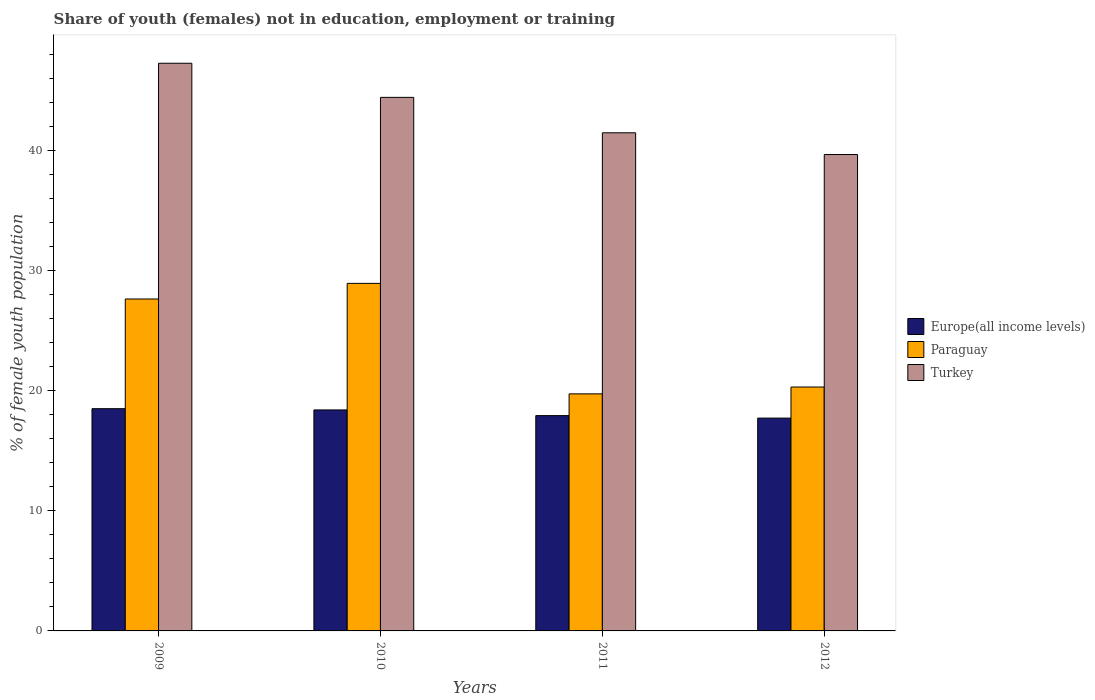How many different coloured bars are there?
Offer a terse response. 3. Are the number of bars per tick equal to the number of legend labels?
Ensure brevity in your answer.  Yes. What is the percentage of unemployed female population in in Europe(all income levels) in 2010?
Make the answer very short. 18.4. Across all years, what is the maximum percentage of unemployed female population in in Europe(all income levels)?
Your response must be concise. 18.51. Across all years, what is the minimum percentage of unemployed female population in in Turkey?
Your answer should be compact. 39.67. What is the total percentage of unemployed female population in in Turkey in the graph?
Your response must be concise. 172.85. What is the difference between the percentage of unemployed female population in in Turkey in 2009 and that in 2010?
Your response must be concise. 2.84. What is the difference between the percentage of unemployed female population in in Paraguay in 2011 and the percentage of unemployed female population in in Turkey in 2009?
Your response must be concise. -27.53. What is the average percentage of unemployed female population in in Turkey per year?
Give a very brief answer. 43.21. In the year 2011, what is the difference between the percentage of unemployed female population in in Europe(all income levels) and percentage of unemployed female population in in Paraguay?
Your response must be concise. -1.81. What is the ratio of the percentage of unemployed female population in in Europe(all income levels) in 2010 to that in 2012?
Your answer should be very brief. 1.04. Is the percentage of unemployed female population in in Paraguay in 2009 less than that in 2011?
Offer a terse response. No. Is the difference between the percentage of unemployed female population in in Europe(all income levels) in 2009 and 2012 greater than the difference between the percentage of unemployed female population in in Paraguay in 2009 and 2012?
Offer a very short reply. No. What is the difference between the highest and the second highest percentage of unemployed female population in in Turkey?
Make the answer very short. 2.84. What is the difference between the highest and the lowest percentage of unemployed female population in in Turkey?
Your response must be concise. 7.6. In how many years, is the percentage of unemployed female population in in Europe(all income levels) greater than the average percentage of unemployed female population in in Europe(all income levels) taken over all years?
Provide a succinct answer. 2. Is the sum of the percentage of unemployed female population in in Paraguay in 2009 and 2011 greater than the maximum percentage of unemployed female population in in Europe(all income levels) across all years?
Give a very brief answer. Yes. What does the 1st bar from the left in 2012 represents?
Offer a terse response. Europe(all income levels). What does the 3rd bar from the right in 2010 represents?
Your answer should be very brief. Europe(all income levels). Are all the bars in the graph horizontal?
Provide a succinct answer. No. How many years are there in the graph?
Offer a terse response. 4. What is the difference between two consecutive major ticks on the Y-axis?
Provide a succinct answer. 10. Where does the legend appear in the graph?
Provide a short and direct response. Center right. How many legend labels are there?
Ensure brevity in your answer.  3. What is the title of the graph?
Give a very brief answer. Share of youth (females) not in education, employment or training. What is the label or title of the X-axis?
Offer a terse response. Years. What is the label or title of the Y-axis?
Keep it short and to the point. % of female youth population. What is the % of female youth population in Europe(all income levels) in 2009?
Your answer should be very brief. 18.51. What is the % of female youth population in Paraguay in 2009?
Give a very brief answer. 27.64. What is the % of female youth population of Turkey in 2009?
Offer a terse response. 47.27. What is the % of female youth population in Europe(all income levels) in 2010?
Your answer should be very brief. 18.4. What is the % of female youth population in Paraguay in 2010?
Provide a succinct answer. 28.94. What is the % of female youth population of Turkey in 2010?
Provide a short and direct response. 44.43. What is the % of female youth population in Europe(all income levels) in 2011?
Your answer should be compact. 17.93. What is the % of female youth population in Paraguay in 2011?
Give a very brief answer. 19.74. What is the % of female youth population of Turkey in 2011?
Offer a very short reply. 41.48. What is the % of female youth population in Europe(all income levels) in 2012?
Your answer should be very brief. 17.72. What is the % of female youth population of Paraguay in 2012?
Your answer should be compact. 20.31. What is the % of female youth population in Turkey in 2012?
Offer a terse response. 39.67. Across all years, what is the maximum % of female youth population of Europe(all income levels)?
Your answer should be very brief. 18.51. Across all years, what is the maximum % of female youth population in Paraguay?
Offer a terse response. 28.94. Across all years, what is the maximum % of female youth population in Turkey?
Your response must be concise. 47.27. Across all years, what is the minimum % of female youth population of Europe(all income levels)?
Keep it short and to the point. 17.72. Across all years, what is the minimum % of female youth population in Paraguay?
Offer a terse response. 19.74. Across all years, what is the minimum % of female youth population of Turkey?
Offer a very short reply. 39.67. What is the total % of female youth population in Europe(all income levels) in the graph?
Give a very brief answer. 72.56. What is the total % of female youth population in Paraguay in the graph?
Give a very brief answer. 96.63. What is the total % of female youth population of Turkey in the graph?
Keep it short and to the point. 172.85. What is the difference between the % of female youth population in Europe(all income levels) in 2009 and that in 2010?
Provide a succinct answer. 0.1. What is the difference between the % of female youth population in Paraguay in 2009 and that in 2010?
Make the answer very short. -1.3. What is the difference between the % of female youth population of Turkey in 2009 and that in 2010?
Make the answer very short. 2.84. What is the difference between the % of female youth population in Europe(all income levels) in 2009 and that in 2011?
Make the answer very short. 0.58. What is the difference between the % of female youth population of Turkey in 2009 and that in 2011?
Provide a short and direct response. 5.79. What is the difference between the % of female youth population in Europe(all income levels) in 2009 and that in 2012?
Keep it short and to the point. 0.79. What is the difference between the % of female youth population of Paraguay in 2009 and that in 2012?
Keep it short and to the point. 7.33. What is the difference between the % of female youth population of Europe(all income levels) in 2010 and that in 2011?
Ensure brevity in your answer.  0.47. What is the difference between the % of female youth population in Paraguay in 2010 and that in 2011?
Ensure brevity in your answer.  9.2. What is the difference between the % of female youth population in Turkey in 2010 and that in 2011?
Give a very brief answer. 2.95. What is the difference between the % of female youth population in Europe(all income levels) in 2010 and that in 2012?
Provide a succinct answer. 0.68. What is the difference between the % of female youth population in Paraguay in 2010 and that in 2012?
Your answer should be compact. 8.63. What is the difference between the % of female youth population of Turkey in 2010 and that in 2012?
Your answer should be compact. 4.76. What is the difference between the % of female youth population of Europe(all income levels) in 2011 and that in 2012?
Give a very brief answer. 0.21. What is the difference between the % of female youth population of Paraguay in 2011 and that in 2012?
Provide a succinct answer. -0.57. What is the difference between the % of female youth population of Turkey in 2011 and that in 2012?
Your answer should be very brief. 1.81. What is the difference between the % of female youth population in Europe(all income levels) in 2009 and the % of female youth population in Paraguay in 2010?
Provide a succinct answer. -10.43. What is the difference between the % of female youth population in Europe(all income levels) in 2009 and the % of female youth population in Turkey in 2010?
Offer a very short reply. -25.92. What is the difference between the % of female youth population in Paraguay in 2009 and the % of female youth population in Turkey in 2010?
Your answer should be compact. -16.79. What is the difference between the % of female youth population of Europe(all income levels) in 2009 and the % of female youth population of Paraguay in 2011?
Provide a succinct answer. -1.23. What is the difference between the % of female youth population of Europe(all income levels) in 2009 and the % of female youth population of Turkey in 2011?
Make the answer very short. -22.97. What is the difference between the % of female youth population in Paraguay in 2009 and the % of female youth population in Turkey in 2011?
Your answer should be compact. -13.84. What is the difference between the % of female youth population in Europe(all income levels) in 2009 and the % of female youth population in Paraguay in 2012?
Make the answer very short. -1.8. What is the difference between the % of female youth population of Europe(all income levels) in 2009 and the % of female youth population of Turkey in 2012?
Provide a short and direct response. -21.16. What is the difference between the % of female youth population in Paraguay in 2009 and the % of female youth population in Turkey in 2012?
Your response must be concise. -12.03. What is the difference between the % of female youth population of Europe(all income levels) in 2010 and the % of female youth population of Paraguay in 2011?
Give a very brief answer. -1.34. What is the difference between the % of female youth population of Europe(all income levels) in 2010 and the % of female youth population of Turkey in 2011?
Offer a very short reply. -23.08. What is the difference between the % of female youth population of Paraguay in 2010 and the % of female youth population of Turkey in 2011?
Offer a very short reply. -12.54. What is the difference between the % of female youth population in Europe(all income levels) in 2010 and the % of female youth population in Paraguay in 2012?
Keep it short and to the point. -1.91. What is the difference between the % of female youth population in Europe(all income levels) in 2010 and the % of female youth population in Turkey in 2012?
Your answer should be very brief. -21.27. What is the difference between the % of female youth population of Paraguay in 2010 and the % of female youth population of Turkey in 2012?
Offer a very short reply. -10.73. What is the difference between the % of female youth population in Europe(all income levels) in 2011 and the % of female youth population in Paraguay in 2012?
Your response must be concise. -2.38. What is the difference between the % of female youth population of Europe(all income levels) in 2011 and the % of female youth population of Turkey in 2012?
Offer a very short reply. -21.74. What is the difference between the % of female youth population of Paraguay in 2011 and the % of female youth population of Turkey in 2012?
Offer a very short reply. -19.93. What is the average % of female youth population of Europe(all income levels) per year?
Offer a terse response. 18.14. What is the average % of female youth population in Paraguay per year?
Offer a terse response. 24.16. What is the average % of female youth population of Turkey per year?
Provide a short and direct response. 43.21. In the year 2009, what is the difference between the % of female youth population in Europe(all income levels) and % of female youth population in Paraguay?
Make the answer very short. -9.13. In the year 2009, what is the difference between the % of female youth population in Europe(all income levels) and % of female youth population in Turkey?
Ensure brevity in your answer.  -28.76. In the year 2009, what is the difference between the % of female youth population in Paraguay and % of female youth population in Turkey?
Provide a short and direct response. -19.63. In the year 2010, what is the difference between the % of female youth population of Europe(all income levels) and % of female youth population of Paraguay?
Give a very brief answer. -10.54. In the year 2010, what is the difference between the % of female youth population of Europe(all income levels) and % of female youth population of Turkey?
Make the answer very short. -26.03. In the year 2010, what is the difference between the % of female youth population in Paraguay and % of female youth population in Turkey?
Your response must be concise. -15.49. In the year 2011, what is the difference between the % of female youth population of Europe(all income levels) and % of female youth population of Paraguay?
Keep it short and to the point. -1.81. In the year 2011, what is the difference between the % of female youth population in Europe(all income levels) and % of female youth population in Turkey?
Provide a short and direct response. -23.55. In the year 2011, what is the difference between the % of female youth population in Paraguay and % of female youth population in Turkey?
Offer a very short reply. -21.74. In the year 2012, what is the difference between the % of female youth population of Europe(all income levels) and % of female youth population of Paraguay?
Provide a succinct answer. -2.59. In the year 2012, what is the difference between the % of female youth population of Europe(all income levels) and % of female youth population of Turkey?
Your response must be concise. -21.95. In the year 2012, what is the difference between the % of female youth population of Paraguay and % of female youth population of Turkey?
Provide a short and direct response. -19.36. What is the ratio of the % of female youth population of Paraguay in 2009 to that in 2010?
Your response must be concise. 0.96. What is the ratio of the % of female youth population of Turkey in 2009 to that in 2010?
Keep it short and to the point. 1.06. What is the ratio of the % of female youth population in Europe(all income levels) in 2009 to that in 2011?
Provide a succinct answer. 1.03. What is the ratio of the % of female youth population of Paraguay in 2009 to that in 2011?
Your response must be concise. 1.4. What is the ratio of the % of female youth population of Turkey in 2009 to that in 2011?
Make the answer very short. 1.14. What is the ratio of the % of female youth population in Europe(all income levels) in 2009 to that in 2012?
Keep it short and to the point. 1.04. What is the ratio of the % of female youth population of Paraguay in 2009 to that in 2012?
Keep it short and to the point. 1.36. What is the ratio of the % of female youth population of Turkey in 2009 to that in 2012?
Your answer should be very brief. 1.19. What is the ratio of the % of female youth population in Europe(all income levels) in 2010 to that in 2011?
Provide a succinct answer. 1.03. What is the ratio of the % of female youth population of Paraguay in 2010 to that in 2011?
Your answer should be compact. 1.47. What is the ratio of the % of female youth population in Turkey in 2010 to that in 2011?
Ensure brevity in your answer.  1.07. What is the ratio of the % of female youth population in Europe(all income levels) in 2010 to that in 2012?
Make the answer very short. 1.04. What is the ratio of the % of female youth population of Paraguay in 2010 to that in 2012?
Offer a very short reply. 1.42. What is the ratio of the % of female youth population in Turkey in 2010 to that in 2012?
Give a very brief answer. 1.12. What is the ratio of the % of female youth population in Europe(all income levels) in 2011 to that in 2012?
Provide a succinct answer. 1.01. What is the ratio of the % of female youth population in Paraguay in 2011 to that in 2012?
Your response must be concise. 0.97. What is the ratio of the % of female youth population in Turkey in 2011 to that in 2012?
Ensure brevity in your answer.  1.05. What is the difference between the highest and the second highest % of female youth population of Europe(all income levels)?
Offer a very short reply. 0.1. What is the difference between the highest and the second highest % of female youth population of Paraguay?
Ensure brevity in your answer.  1.3. What is the difference between the highest and the second highest % of female youth population of Turkey?
Your answer should be compact. 2.84. What is the difference between the highest and the lowest % of female youth population in Europe(all income levels)?
Keep it short and to the point. 0.79. What is the difference between the highest and the lowest % of female youth population in Paraguay?
Keep it short and to the point. 9.2. 